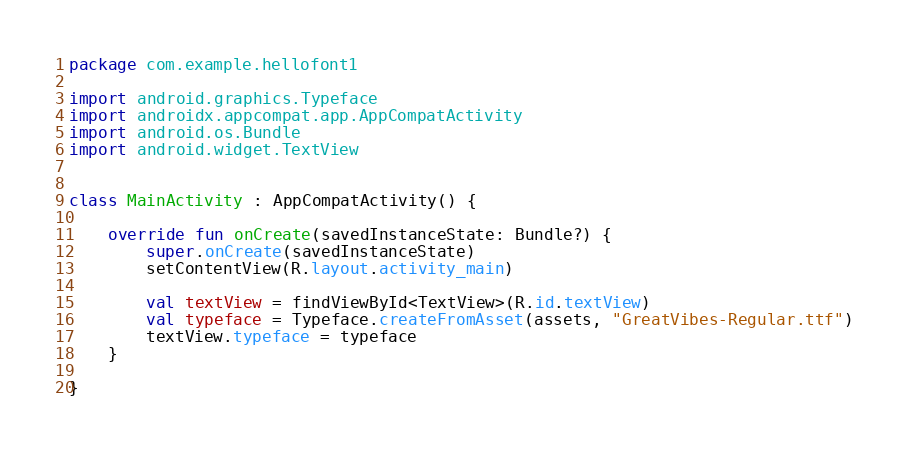<code> <loc_0><loc_0><loc_500><loc_500><_Kotlin_>package com.example.hellofont1

import android.graphics.Typeface
import androidx.appcompat.app.AppCompatActivity
import android.os.Bundle
import android.widget.TextView


class MainActivity : AppCompatActivity() {

    override fun onCreate(savedInstanceState: Bundle?) {
        super.onCreate(savedInstanceState)
        setContentView(R.layout.activity_main)

        val textView = findViewById<TextView>(R.id.textView)
        val typeface = Typeface.createFromAsset(assets, "GreatVibes-Regular.ttf")
        textView.typeface = typeface
    }

}
</code> 